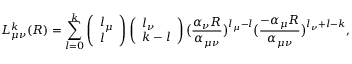<formula> <loc_0><loc_0><loc_500><loc_500>L _ { \mu \nu } ^ { k } ( R ) = \sum _ { l = 0 } ^ { k } \left ( \begin{array} { l } { l _ { \mu } } \\ { l } \end{array} \right ) \left ( \begin{array} { l } { l _ { \nu } } \\ { k - l } \end{array} \right ) \left ( \frac { \alpha _ { \nu } R } { \alpha _ { \mu \nu } } \right ) ^ { l _ { \mu } - l } \left ( \frac { - \alpha _ { \mu } R } { \alpha _ { \mu \nu } } \right ) ^ { l _ { \nu } + l - k } ,</formula> 